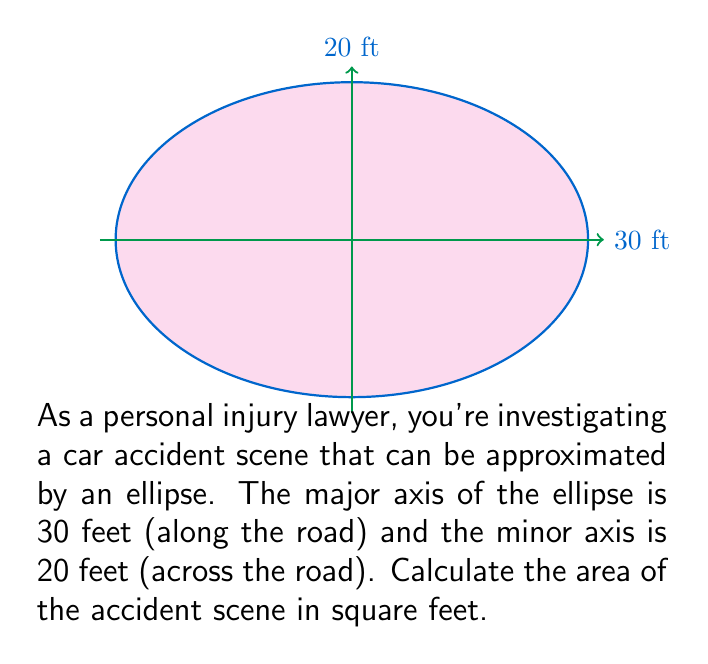Give your solution to this math problem. To calculate the area of an ellipse, we use the formula:

$$A = \pi ab$$

Where:
$A$ = area of the ellipse
$a$ = length of semi-major axis (half of the major axis)
$b$ = length of semi-minor axis (half of the minor axis)

Given:
Major axis = 30 feet
Minor axis = 20 feet

Step 1: Calculate the semi-major and semi-minor axes
$a = 30 / 2 = 15$ feet
$b = 20 / 2 = 10$ feet

Step 2: Apply the formula
$$A = \pi ab$$
$$A = \pi(15)(10)$$
$$A = 150\pi$$

Step 3: Calculate the final result
$$A = 150\pi \approx 471.24 \text{ sq ft}$$

Therefore, the approximate area of the accident scene is 471.24 square feet.
Answer: $471.24 \text{ sq ft}$ 